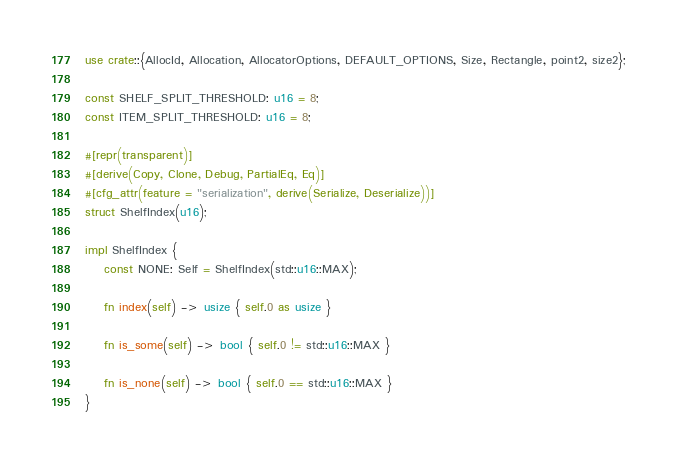<code> <loc_0><loc_0><loc_500><loc_500><_Rust_>use crate::{AllocId, Allocation, AllocatorOptions, DEFAULT_OPTIONS, Size, Rectangle, point2, size2};

const SHELF_SPLIT_THRESHOLD: u16 = 8;
const ITEM_SPLIT_THRESHOLD: u16 = 8;

#[repr(transparent)]
#[derive(Copy, Clone, Debug, PartialEq, Eq)]
#[cfg_attr(feature = "serialization", derive(Serialize, Deserialize))]
struct ShelfIndex(u16);

impl ShelfIndex {
    const NONE: Self = ShelfIndex(std::u16::MAX);

    fn index(self) -> usize { self.0 as usize }

    fn is_some(self) -> bool { self.0 != std::u16::MAX }

    fn is_none(self) -> bool { self.0 == std::u16::MAX }
}
</code> 